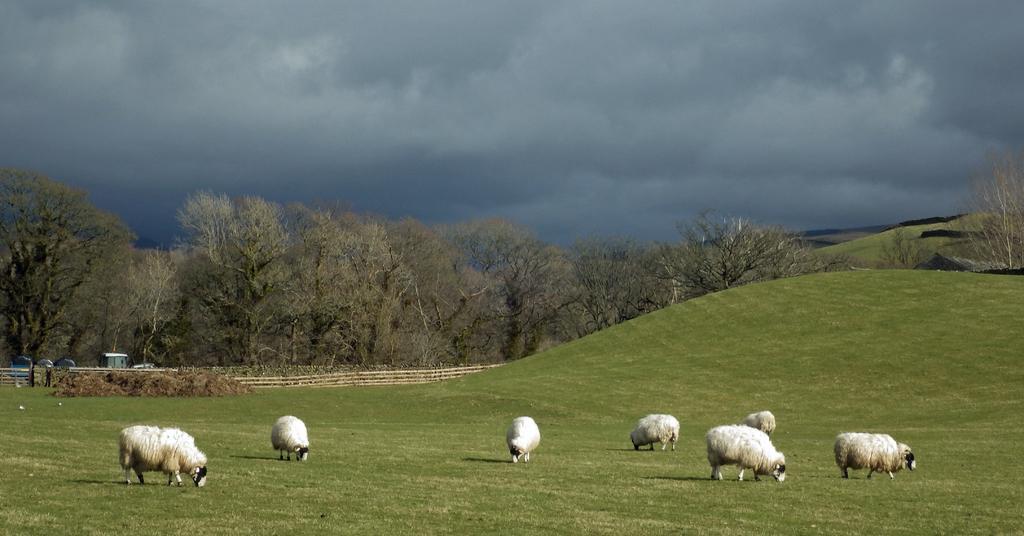Can you describe this image briefly? In this picture we can observe sheep grazing grass on the ground. There are some trees and a railing here. In the background there is a sky with some clouds. 